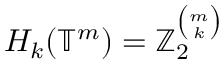Convert formula to latex. <formula><loc_0><loc_0><loc_500><loc_500>H _ { k } ( \mathbb { T } ^ { m } ) = \mathbb { Z } _ { 2 } ^ { \binom { m } { k } }</formula> 